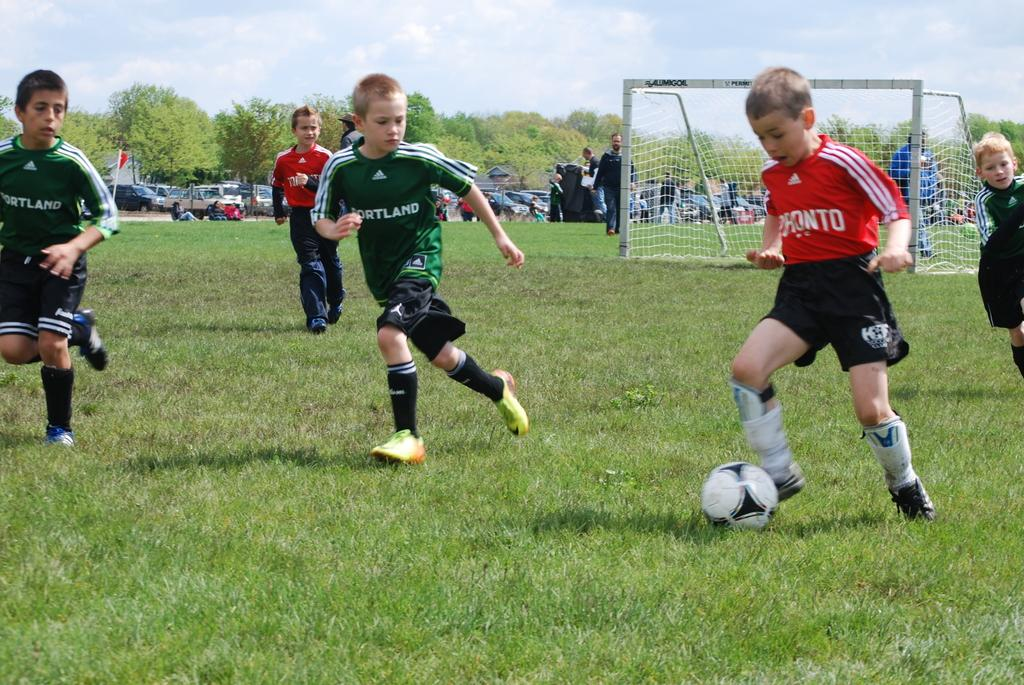<image>
Relay a brief, clear account of the picture shown. The players in the green uniforms are on the Portland team. 